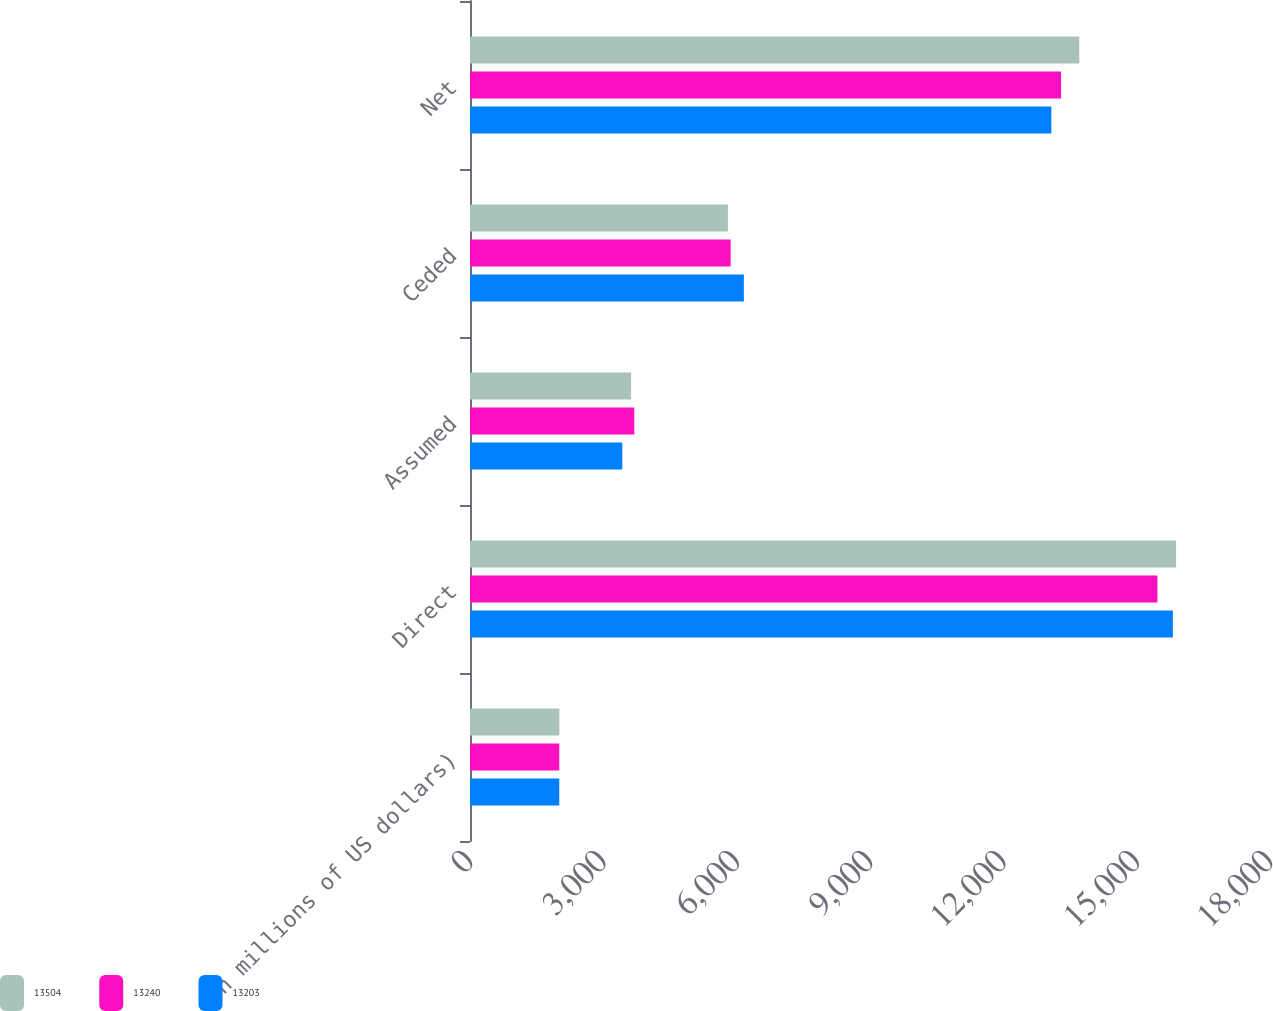<chart> <loc_0><loc_0><loc_500><loc_500><stacked_bar_chart><ecel><fcel>(in millions of US dollars)<fcel>Direct<fcel>Assumed<fcel>Ceded<fcel>Net<nl><fcel>13504<fcel>2010<fcel>15887<fcel>3624<fcel>5803<fcel>13708<nl><fcel>13240<fcel>2009<fcel>15467<fcel>3697<fcel>5865<fcel>13299<nl><fcel>13203<fcel>2008<fcel>15815<fcel>3427<fcel>6162<fcel>13080<nl></chart> 